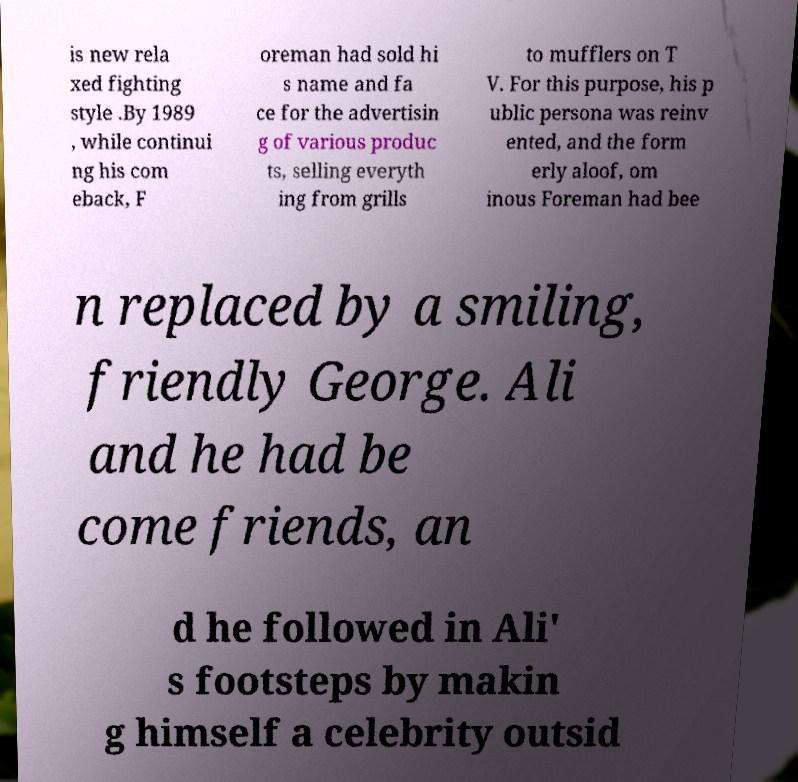Please read and relay the text visible in this image. What does it say? is new rela xed fighting style .By 1989 , while continui ng his com eback, F oreman had sold hi s name and fa ce for the advertisin g of various produc ts, selling everyth ing from grills to mufflers on T V. For this purpose, his p ublic persona was reinv ented, and the form erly aloof, om inous Foreman had bee n replaced by a smiling, friendly George. Ali and he had be come friends, an d he followed in Ali' s footsteps by makin g himself a celebrity outsid 